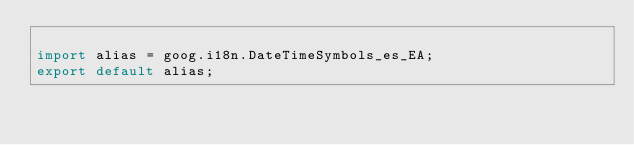<code> <loc_0><loc_0><loc_500><loc_500><_TypeScript_>
import alias = goog.i18n.DateTimeSymbols_es_EA;
export default alias;
</code> 